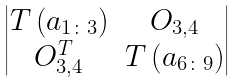<formula> <loc_0><loc_0><loc_500><loc_500>\begin{vmatrix} T \left ( a _ { 1 \colon 3 } \right ) & O _ { 3 , 4 } \\ O _ { 3 , 4 } ^ { T } & T \left ( a _ { 6 \colon 9 } \right ) \end{vmatrix}</formula> 